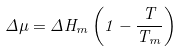Convert formula to latex. <formula><loc_0><loc_0><loc_500><loc_500>\Delta \mu = \Delta H _ { m } \left ( 1 - \frac { T } { T _ { m } } \right )</formula> 